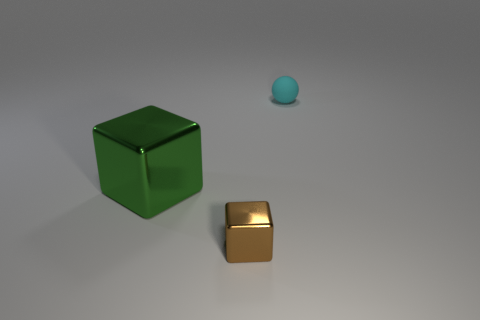There is a green thing that is the same shape as the tiny brown thing; what material is it? The green object, which has a cubic shape similar to the smaller brown one, appears to be made of a reflective material, possibly polished metal or plastic with a metallic paint finish. 